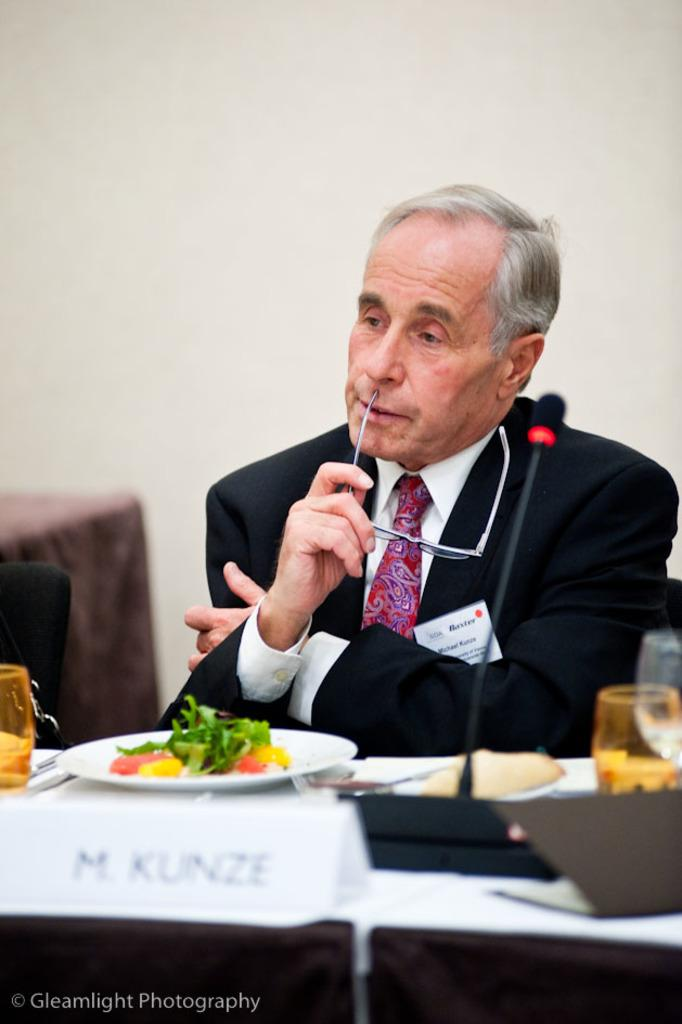Who is present in the image? There is a man in the image. What is the man holding in the image? The man is holding a pair of glasses (specs). What objects can be seen on the table in the image? There are glasses, a microphone (mic), and food on a plate on the table. What type of hole can be seen in the image? There is no hole present in the image. What type of thread is being used by the writer in the image? There is no writer or thread present in the image. 